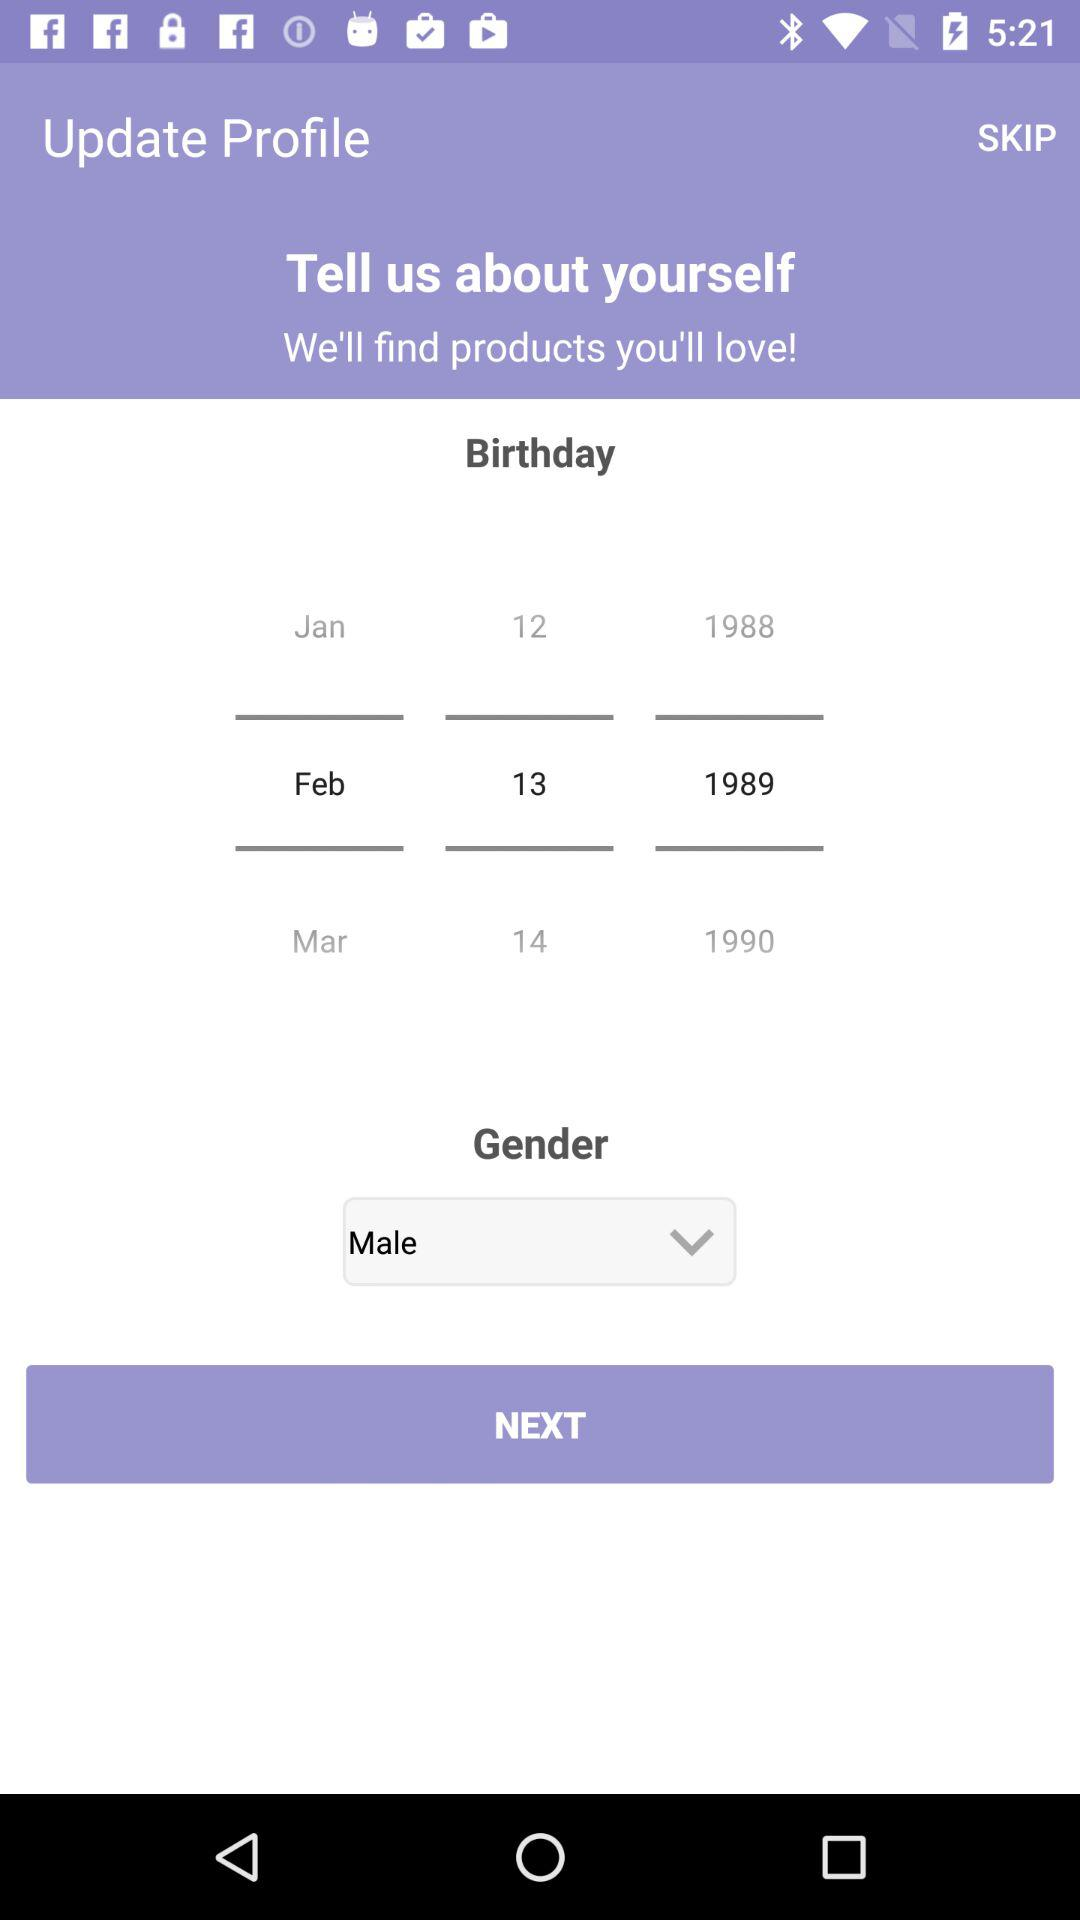What is the date of birth of the user? The date of birth of the user is February 13, 1989. 